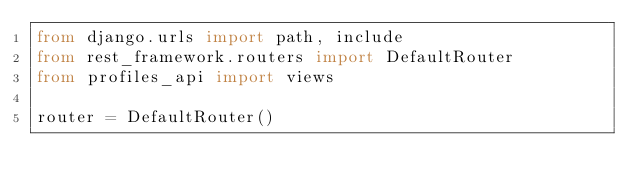<code> <loc_0><loc_0><loc_500><loc_500><_Python_>from django.urls import path, include
from rest_framework.routers import DefaultRouter
from profiles_api import views

router = DefaultRouter()</code> 